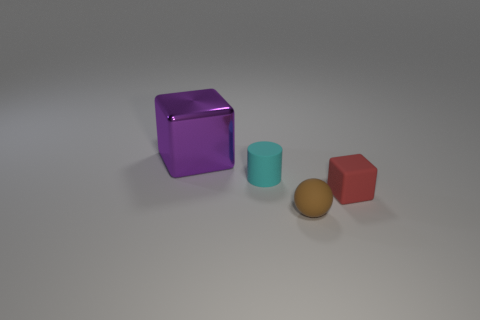Add 2 cyan objects. How many objects exist? 6 Subtract all spheres. How many objects are left? 3 Subtract 0 brown cylinders. How many objects are left? 4 Subtract all gray shiny spheres. Subtract all brown matte balls. How many objects are left? 3 Add 1 purple things. How many purple things are left? 2 Add 4 matte balls. How many matte balls exist? 5 